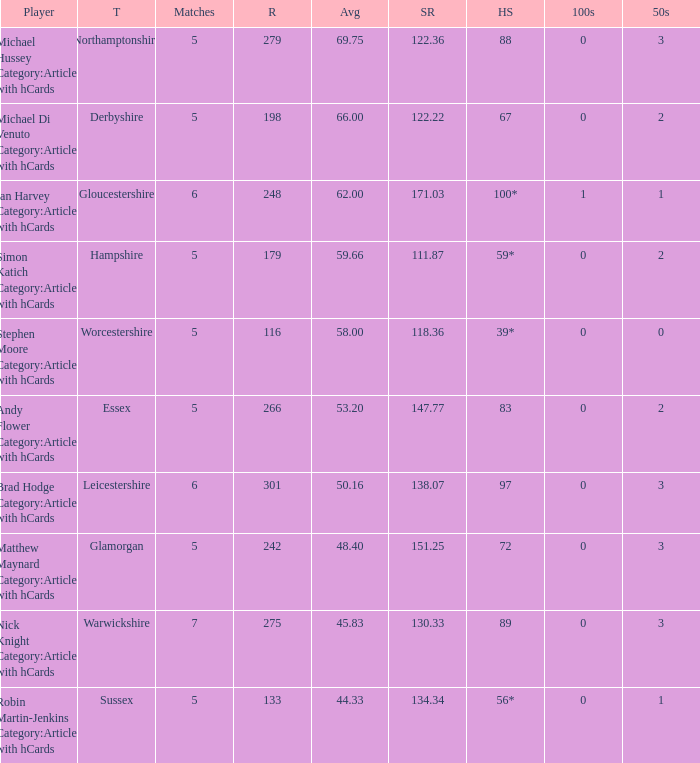What is the team Sussex' highest score? 56*. 